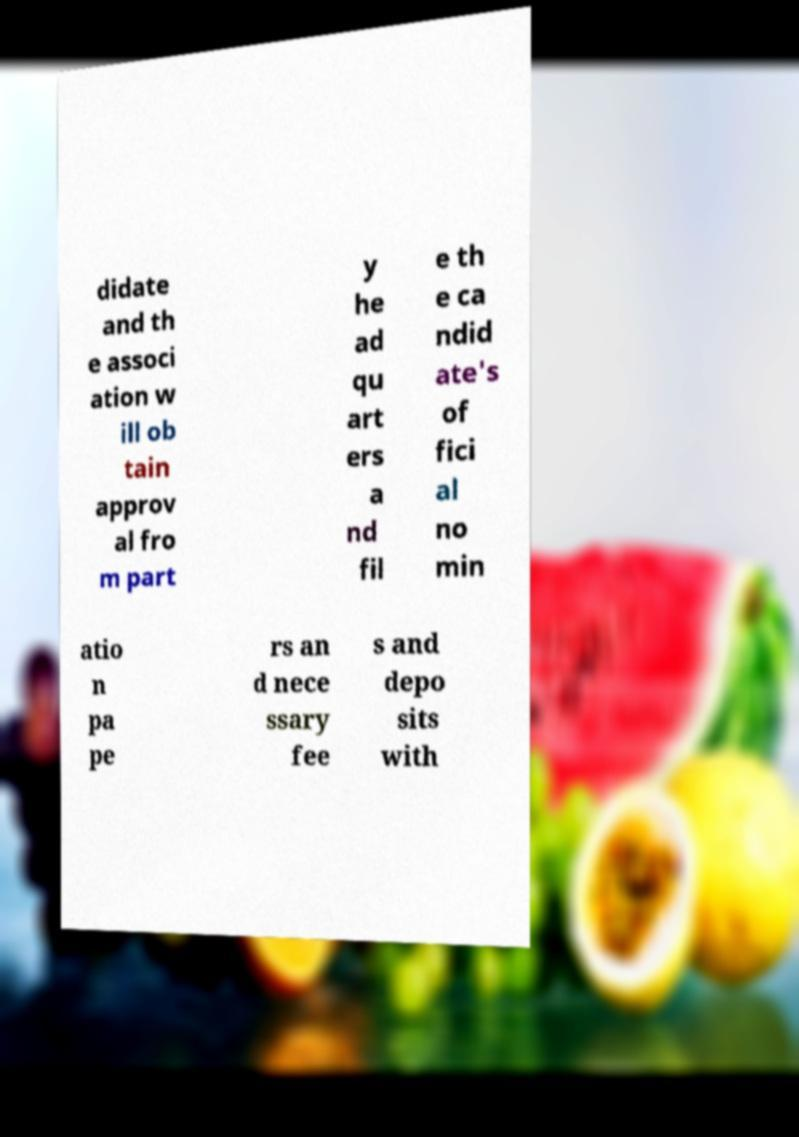What messages or text are displayed in this image? I need them in a readable, typed format. didate and th e associ ation w ill ob tain approv al fro m part y he ad qu art ers a nd fil e th e ca ndid ate's of fici al no min atio n pa pe rs an d nece ssary fee s and depo sits with 